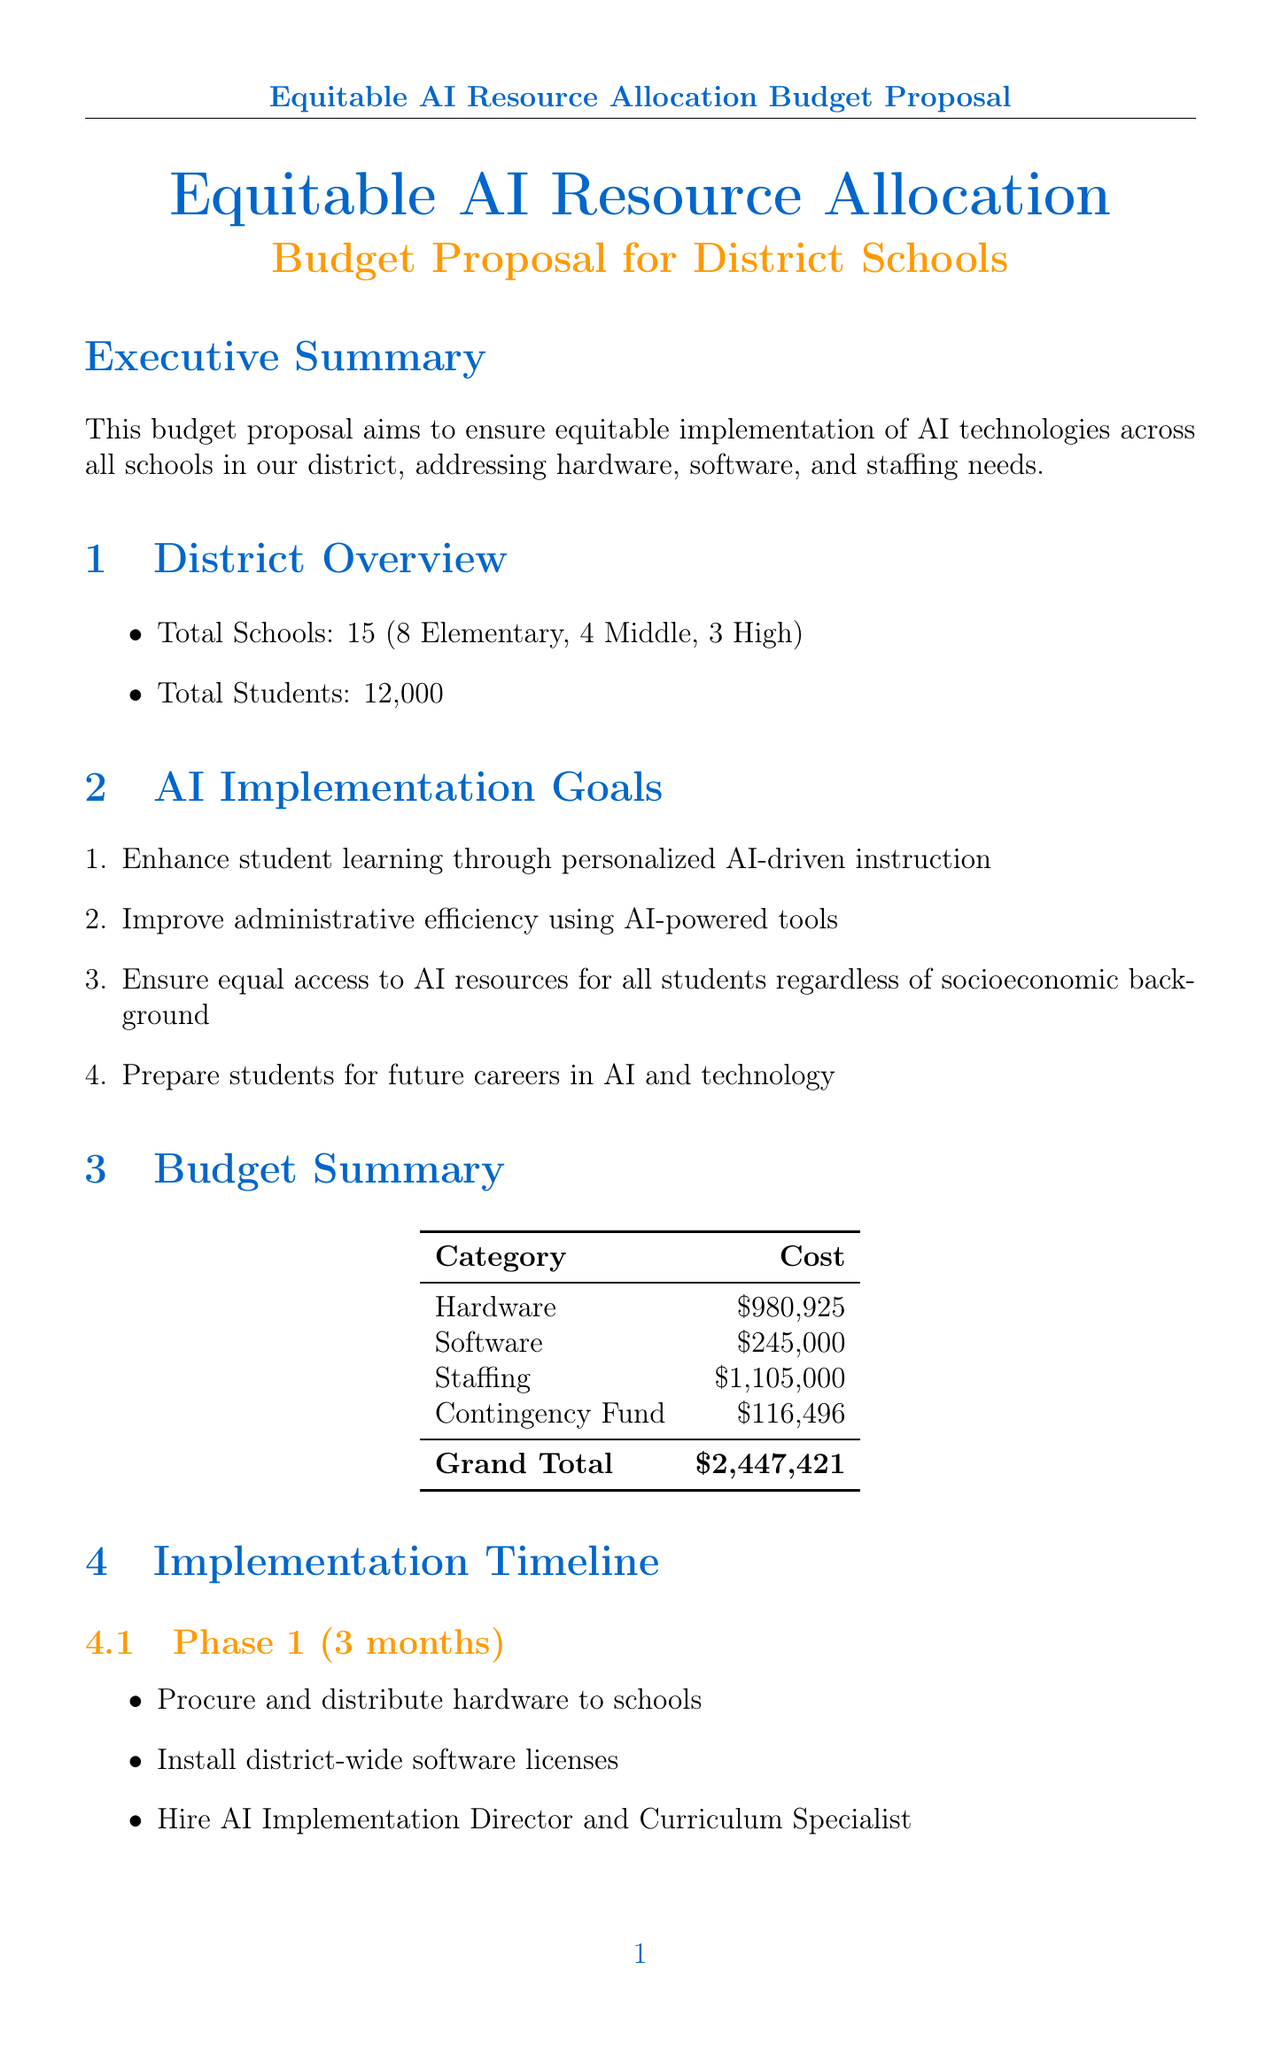What is the total number of schools? The document states that there are a total of 15 schools in the district.
Answer: 15 What percentage of total students are in elementary schools? With 12,000 total students and 8 elementary schools, we can calculate that roughly half of the students are in elementary schools.
Answer: Approximately 50% What is the annual cost for the Microsoft Azure AI Platform? The report specifies that the annual cost for the Microsoft Azure AI Platform is $50,000.
Answer: $50,000 How many phases are included in the implementation timeline? The implementation timeline clearly outlines three phases for executing the AI resource allocation.
Answer: 3 What is the total cost for hardware allocation in the district? The budget document lists the total hardware cost for the district as $980,925.
Answer: $980,925 What position is responsible for overseeing district-wide AI implementation? The document indicates that the AI Implementation Director is responsible for this task.
Answer: AI Implementation Director What is the cost of the AI Technology Support Specialist per school? It is stated that the annual salary for the AI Technology Support Specialist is $60,000 per school.
Answer: $60,000 What is one of the equity considerations outlined in the report? The document mentions prioritizing schools with limited existing technology resources as an equity consideration.
Answer: Prioritize schools with limited existing technology resources What is the total budget proposed for equitable AI implementation? The grand total for the budget proposal listed is $2,447,421.
Answer: $2,447,421 